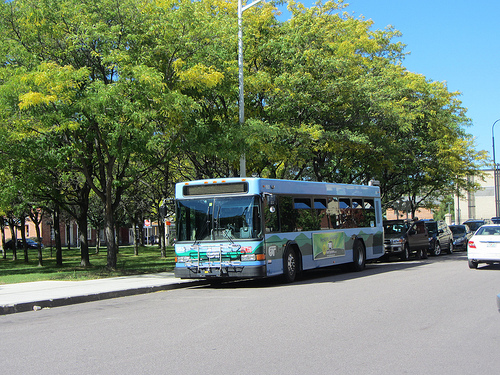Is that bus yellow? No, the bus is not yellow. It is a different color. 